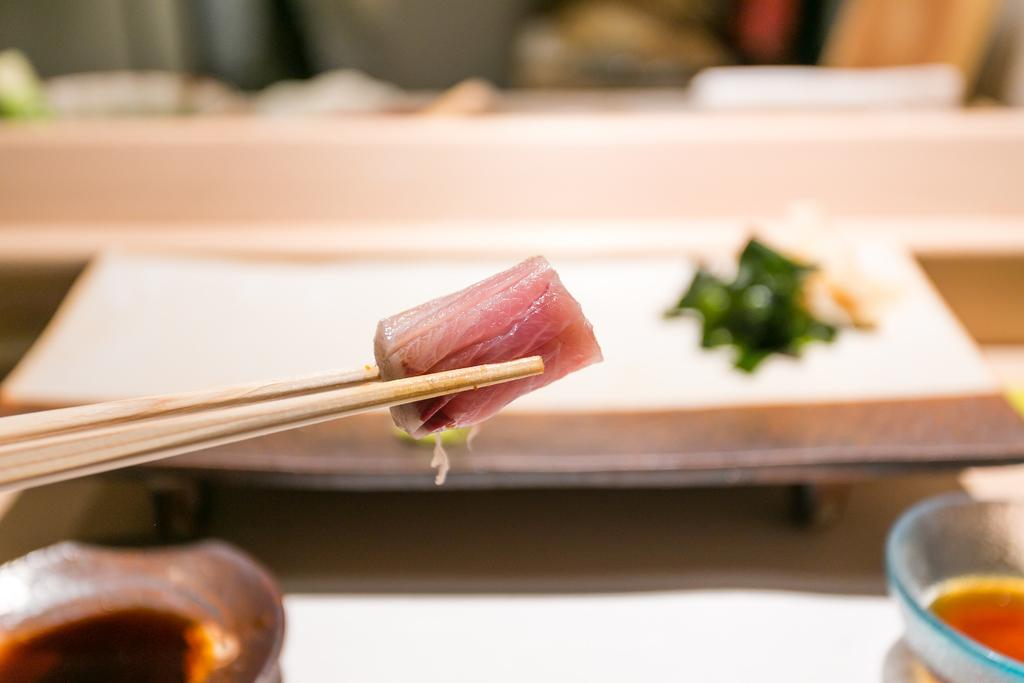What utensils are present in the image? There are chopsticks in the image. What is the chopsticks used with in the image? There is a bowl in the image that the chopsticks might be used with. On what surface are the chopsticks and bowl placed? There is a table in the image where the chopsticks and bowl are placed. What is the distribution of the chopsticks' size in the image? The image does not provide information about the distribution of the chopsticks' size, as there is only one set of chopsticks visible. 